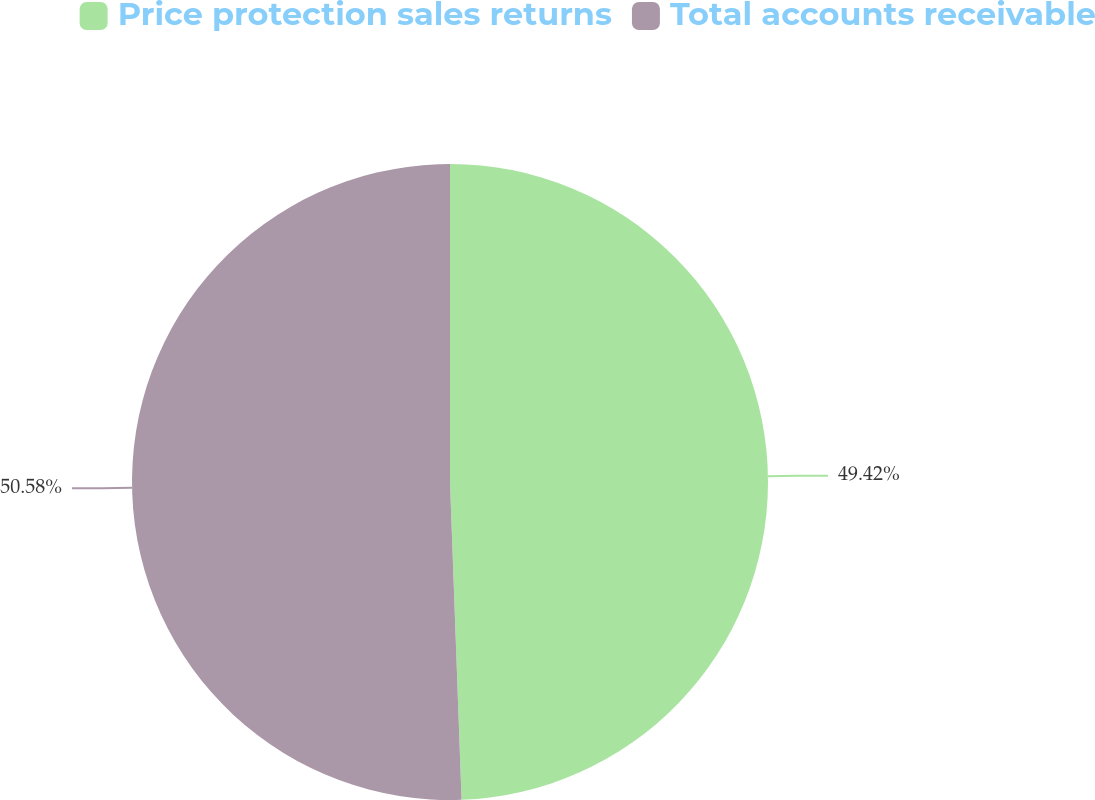Convert chart. <chart><loc_0><loc_0><loc_500><loc_500><pie_chart><fcel>Price protection sales returns<fcel>Total accounts receivable<nl><fcel>49.42%<fcel>50.58%<nl></chart> 